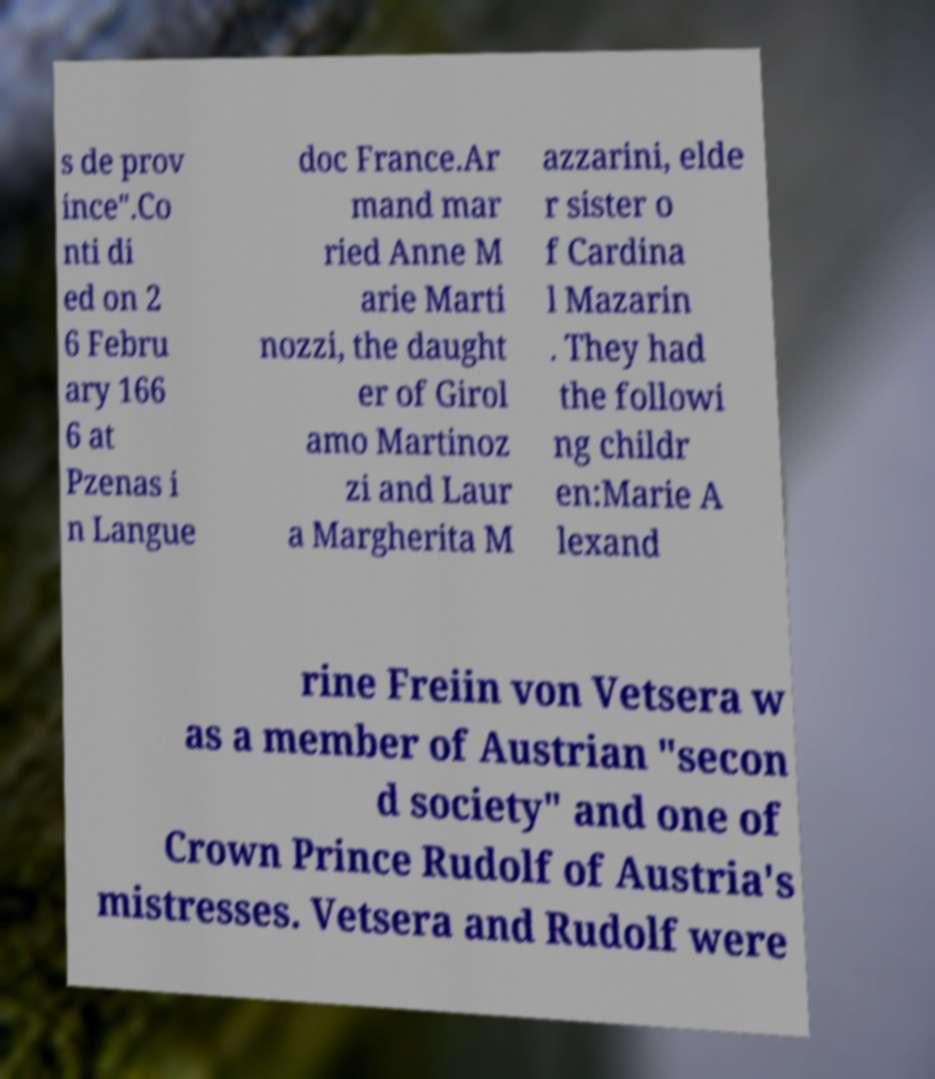Can you read and provide the text displayed in the image?This photo seems to have some interesting text. Can you extract and type it out for me? s de prov ince".Co nti di ed on 2 6 Febru ary 166 6 at Pzenas i n Langue doc France.Ar mand mar ried Anne M arie Marti nozzi, the daught er of Girol amo Martinoz zi and Laur a Margherita M azzarini, elde r sister o f Cardina l Mazarin . They had the followi ng childr en:Marie A lexand rine Freiin von Vetsera w as a member of Austrian "secon d society" and one of Crown Prince Rudolf of Austria's mistresses. Vetsera and Rudolf were 